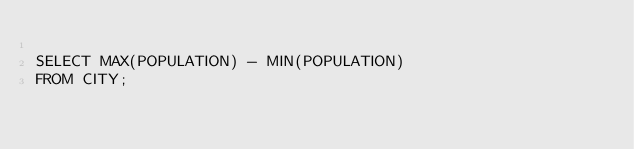Convert code to text. <code><loc_0><loc_0><loc_500><loc_500><_SQL_>
SELECT MAX(POPULATION) - MIN(POPULATION)
FROM CITY;
</code> 